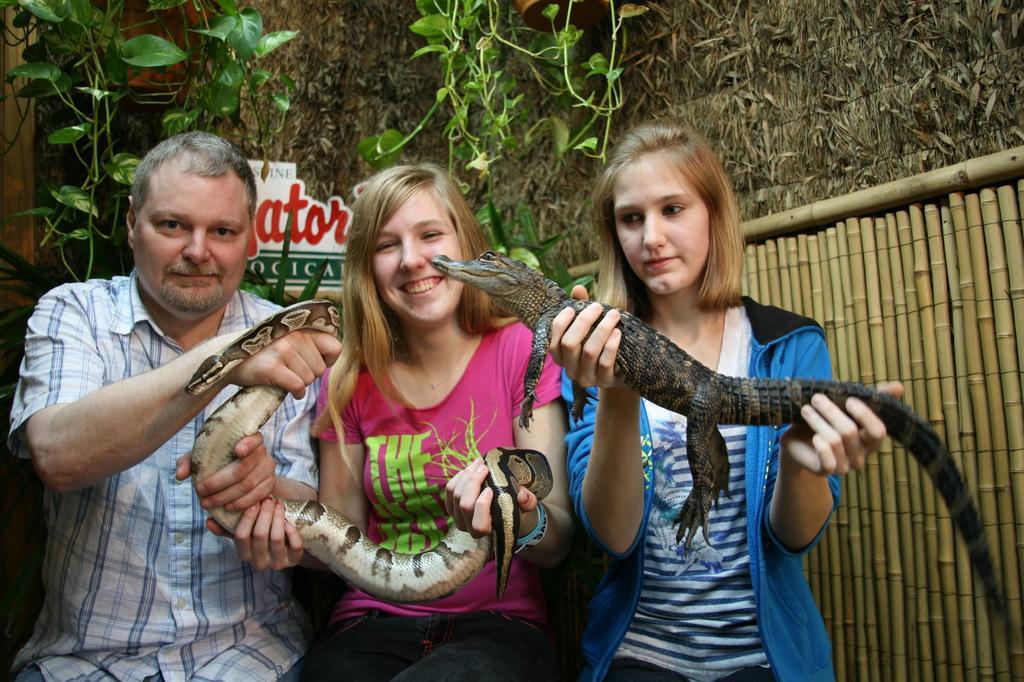In one or two sentences, can you explain what this image depicts? In this image there are three persons who is catching reptiles in their hands and at the background there are trees and wall. 